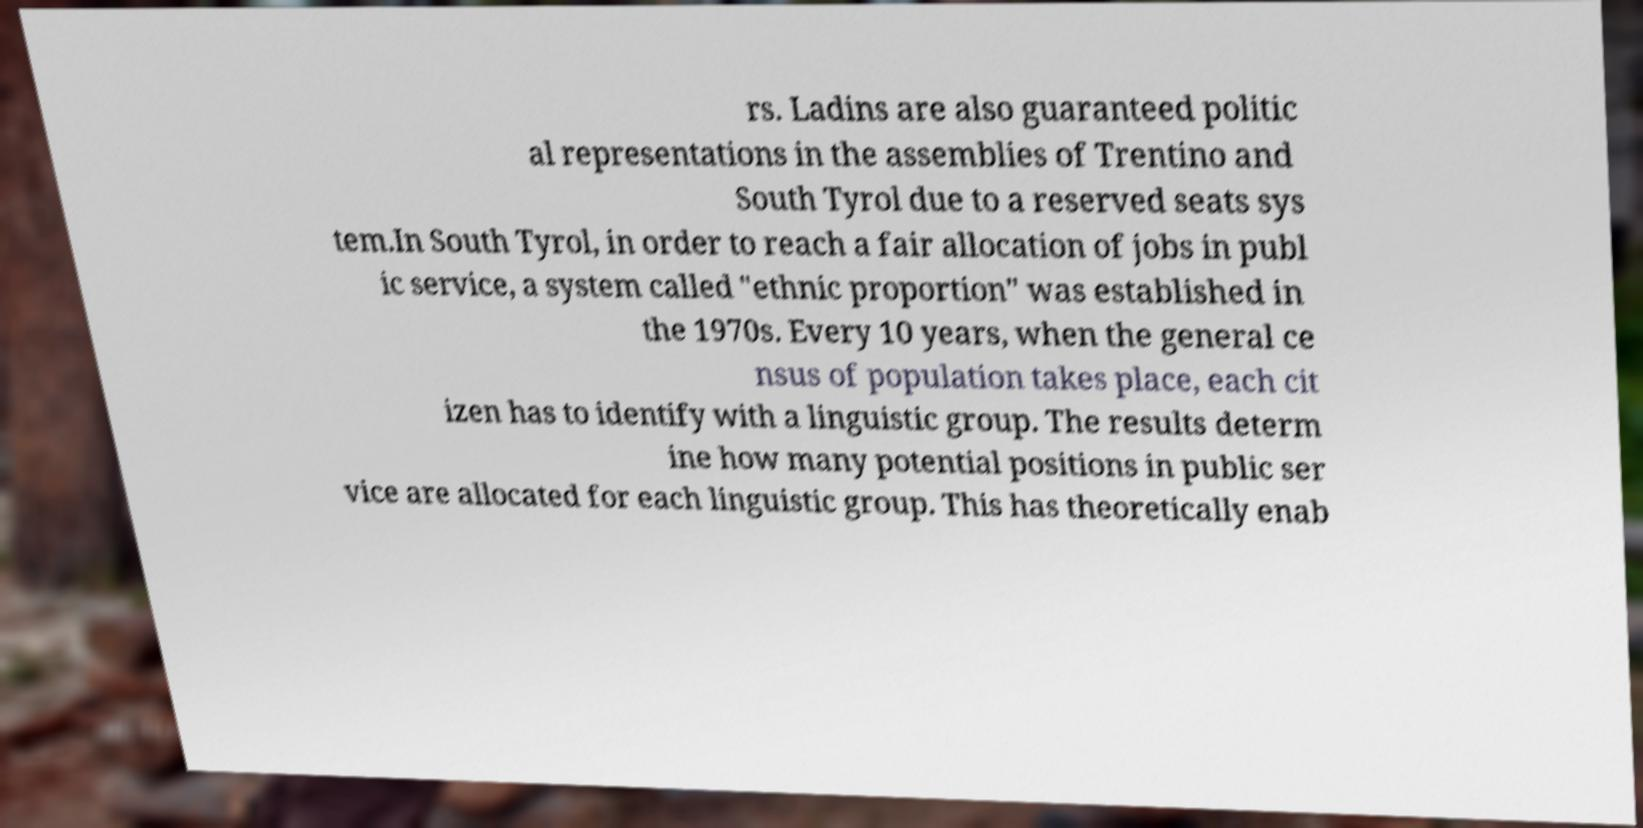Can you read and provide the text displayed in the image?This photo seems to have some interesting text. Can you extract and type it out for me? rs. Ladins are also guaranteed politic al representations in the assemblies of Trentino and South Tyrol due to a reserved seats sys tem.In South Tyrol, in order to reach a fair allocation of jobs in publ ic service, a system called "ethnic proportion" was established in the 1970s. Every 10 years, when the general ce nsus of population takes place, each cit izen has to identify with a linguistic group. The results determ ine how many potential positions in public ser vice are allocated for each linguistic group. This has theoretically enab 